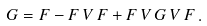Convert formula to latex. <formula><loc_0><loc_0><loc_500><loc_500>G = F - F \, V \, F + F \, V \, G \, V \, F \, .</formula> 